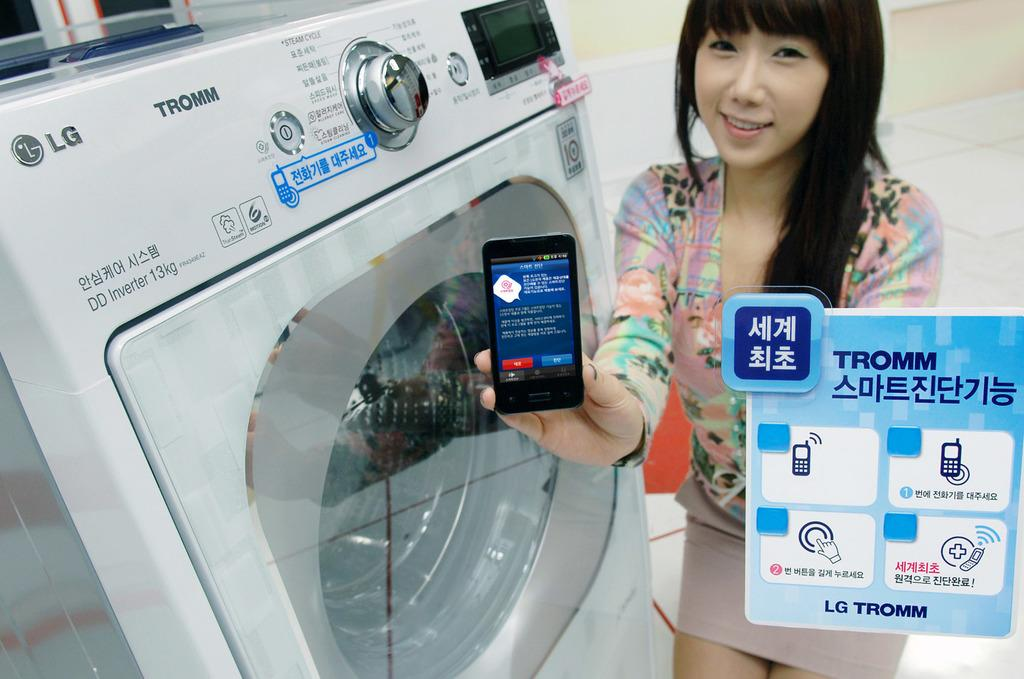<image>
Render a clear and concise summary of the photo. A woman who is holding up a cellphone is standing next to an LG brand washing machine. 